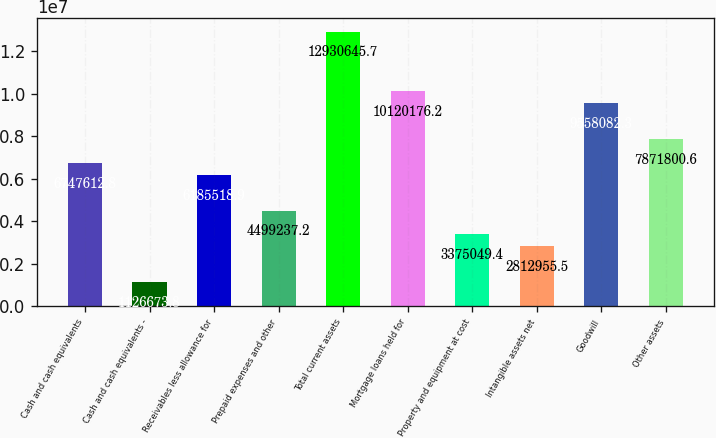Convert chart to OTSL. <chart><loc_0><loc_0><loc_500><loc_500><bar_chart><fcel>Cash and cash equivalents<fcel>Cash and cash equivalents -<fcel>Receivables less allowance for<fcel>Prepaid expenses and other<fcel>Total current assets<fcel>Mortgage loans held for<fcel>Property and equipment at cost<fcel>Intangible assets net<fcel>Goodwill<fcel>Other assets<nl><fcel>6.74761e+06<fcel>1.12667e+06<fcel>6.18552e+06<fcel>4.49924e+06<fcel>1.29306e+07<fcel>1.01202e+07<fcel>3.37505e+06<fcel>2.81296e+06<fcel>9.55808e+06<fcel>7.8718e+06<nl></chart> 